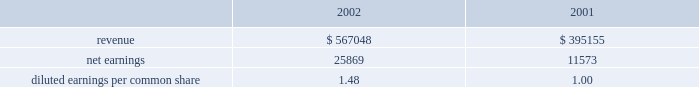Disclosure of , the issuance of certain types of guarantees .
The adoption of fasb interpretation no .
45 did not have a signif- icant impact on the net income or equity of the company .
In january 2003 , fasb interpretation no .
46 , 201cconsolidation of variable interest entities , an interpretation of arb 51 , 201d was issued .
The primary objectives of this interpretation , as amended , are to provide guidance on the identification and consolidation of variable interest entities , or vies , which are entities for which control is achieved through means other than through voting rights .
The company has completed an analysis of this interpretation and has determined that it does not have any vies .
Acquisitions family health plan , inc .
Effective january 1 , 2004 , the company commenced opera- tions in ohio through the acquisition from family health plan , inc .
Of certain medicaid-related assets for a purchase price of approximately $ 6800 .
The cost to acquire the medicaid-related assets will be allocated to the assets acquired and liabilities assumed according to estimated fair values .
Hmo blue texas effective august 1 , 2003 , the company acquired certain medicaid-related contract rights of hmo blue texas in the san antonio , texas market for $ 1045 .
The purchase price was allocated to acquired contracts , which are being amor- tized on a straight-line basis over a period of five years , the expected period of benefit .
Group practice affiliates during 2003 , the company acquired a 100% ( 100 % ) ownership interest in group practice affiliates , llc , a behavioral healthcare services company ( 63.7% ( 63.7 % ) in march 2003 and 36.3% ( 36.3 % ) in august 2003 ) .
The consolidated financial state- ments include the results of operations of gpa since march 1 , 2003 .
The company paid $ 1800 for its purchase of gpa .
The cost to acquire the ownership interest has been allocated to the assets acquired and liabilities assumed according to estimated fair values and is subject to adjustment when additional information concerning asset and liability valuations are finalized .
The preliminary allocation has resulted in goodwill of approximately $ 3895 .
The goodwill is not amortized and is not deductible for tax purposes .
Pro forma disclosures related to the acquisition have been excluded as immaterial .
Scriptassist in march 2003 , the company purchased contract and name rights of scriptassist , llc ( scriptassist ) , a medication com- pliance company .
The purchase price of $ 563 was allocated to acquired contracts , which are being amortized on a straight-line basis over a period of five years , the expected period of benefit .
The investor group who held membership interests in scriptassist included one of the company 2019s executive officers .
University health plans , inc .
On december 1 , 2002 , the company purchased 80% ( 80 % ) of the outstanding capital stock of university health plans , inc .
( uhp ) in new jersey .
In october 2003 , the company exercised its option to purchase the remaining 20% ( 20 % ) of the outstanding capital stock .
Centene paid a total purchase price of $ 13258 .
The results of operations for uhp are included in the consolidated financial statements since december 1 , 2002 .
The acquisition of uhp resulted in identified intangible assets of $ 3800 , representing purchased contract rights and provider network .
The intangibles are being amortized over a ten-year period .
Goodwill of $ 7940 is not amortized and is not deductible for tax purposes .
Changes during 2003 to the preliminary purchase price allocation primarily consisted of the purchase of the remaining 20% ( 20 % ) of the outstanding stock and the recognition of intangible assets and related deferred tax liabilities .
The following unaudited pro forma information presents the results of operations of centene and subsidiaries as if the uhp acquisition described above had occurred as of january 1 , 2001 .
These pro forma results may not necessar- ily reflect the actual results of operations that would have been achieved , nor are they necessarily indicative of future results of operations. .
Diluted earnings per common share 1.48 1.00 texas universities health plan in june 2002 , the company purchased schip contracts in three texas service areas .
The cash purchase price of $ 595 was recorded as purchased contract rights , which are being amortized on a straight-line basis over five years , the expected period of benefit .
Bankers reserve in march 2002 , the company acquired bankers reserve life insurance company of wisconsin for a cash purchase price of $ 3527 .
The company allocated the purchase price to net tangible and identifiable intangible assets based on their fair value .
Centene allocated $ 479 to identifiable intangible assets , representing the value assigned to acquired licenses , which are being amortized on a straight-line basis over a notes to consolidated financial statements ( continued ) centene corporation and subsidiaries .
What was the percentage change in pro forma revenue from 2001 to 2002? 
Computations: ((567048 - 395155) / 395155)
Answer: 0.435. Disclosure of , the issuance of certain types of guarantees .
The adoption of fasb interpretation no .
45 did not have a signif- icant impact on the net income or equity of the company .
In january 2003 , fasb interpretation no .
46 , 201cconsolidation of variable interest entities , an interpretation of arb 51 , 201d was issued .
The primary objectives of this interpretation , as amended , are to provide guidance on the identification and consolidation of variable interest entities , or vies , which are entities for which control is achieved through means other than through voting rights .
The company has completed an analysis of this interpretation and has determined that it does not have any vies .
Acquisitions family health plan , inc .
Effective january 1 , 2004 , the company commenced opera- tions in ohio through the acquisition from family health plan , inc .
Of certain medicaid-related assets for a purchase price of approximately $ 6800 .
The cost to acquire the medicaid-related assets will be allocated to the assets acquired and liabilities assumed according to estimated fair values .
Hmo blue texas effective august 1 , 2003 , the company acquired certain medicaid-related contract rights of hmo blue texas in the san antonio , texas market for $ 1045 .
The purchase price was allocated to acquired contracts , which are being amor- tized on a straight-line basis over a period of five years , the expected period of benefit .
Group practice affiliates during 2003 , the company acquired a 100% ( 100 % ) ownership interest in group practice affiliates , llc , a behavioral healthcare services company ( 63.7% ( 63.7 % ) in march 2003 and 36.3% ( 36.3 % ) in august 2003 ) .
The consolidated financial state- ments include the results of operations of gpa since march 1 , 2003 .
The company paid $ 1800 for its purchase of gpa .
The cost to acquire the ownership interest has been allocated to the assets acquired and liabilities assumed according to estimated fair values and is subject to adjustment when additional information concerning asset and liability valuations are finalized .
The preliminary allocation has resulted in goodwill of approximately $ 3895 .
The goodwill is not amortized and is not deductible for tax purposes .
Pro forma disclosures related to the acquisition have been excluded as immaterial .
Scriptassist in march 2003 , the company purchased contract and name rights of scriptassist , llc ( scriptassist ) , a medication com- pliance company .
The purchase price of $ 563 was allocated to acquired contracts , which are being amortized on a straight-line basis over a period of five years , the expected period of benefit .
The investor group who held membership interests in scriptassist included one of the company 2019s executive officers .
University health plans , inc .
On december 1 , 2002 , the company purchased 80% ( 80 % ) of the outstanding capital stock of university health plans , inc .
( uhp ) in new jersey .
In october 2003 , the company exercised its option to purchase the remaining 20% ( 20 % ) of the outstanding capital stock .
Centene paid a total purchase price of $ 13258 .
The results of operations for uhp are included in the consolidated financial statements since december 1 , 2002 .
The acquisition of uhp resulted in identified intangible assets of $ 3800 , representing purchased contract rights and provider network .
The intangibles are being amortized over a ten-year period .
Goodwill of $ 7940 is not amortized and is not deductible for tax purposes .
Changes during 2003 to the preliminary purchase price allocation primarily consisted of the purchase of the remaining 20% ( 20 % ) of the outstanding stock and the recognition of intangible assets and related deferred tax liabilities .
The following unaudited pro forma information presents the results of operations of centene and subsidiaries as if the uhp acquisition described above had occurred as of january 1 , 2001 .
These pro forma results may not necessar- ily reflect the actual results of operations that would have been achieved , nor are they necessarily indicative of future results of operations. .
Diluted earnings per common share 1.48 1.00 texas universities health plan in june 2002 , the company purchased schip contracts in three texas service areas .
The cash purchase price of $ 595 was recorded as purchased contract rights , which are being amortized on a straight-line basis over five years , the expected period of benefit .
Bankers reserve in march 2002 , the company acquired bankers reserve life insurance company of wisconsin for a cash purchase price of $ 3527 .
The company allocated the purchase price to net tangible and identifiable intangible assets based on their fair value .
Centene allocated $ 479 to identifiable intangible assets , representing the value assigned to acquired licenses , which are being amortized on a straight-line basis over a notes to consolidated financial statements ( continued ) centene corporation and subsidiaries .
What is the annual impact on pretax net income relating the schip purchased contract rights? 
Computations: (595 / 5)
Answer: 119.0. 